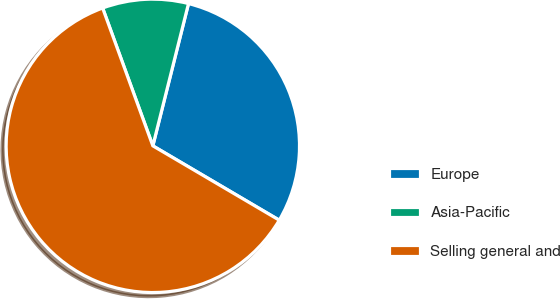Convert chart. <chart><loc_0><loc_0><loc_500><loc_500><pie_chart><fcel>Europe<fcel>Asia-Pacific<fcel>Selling general and<nl><fcel>29.55%<fcel>9.47%<fcel>60.98%<nl></chart> 